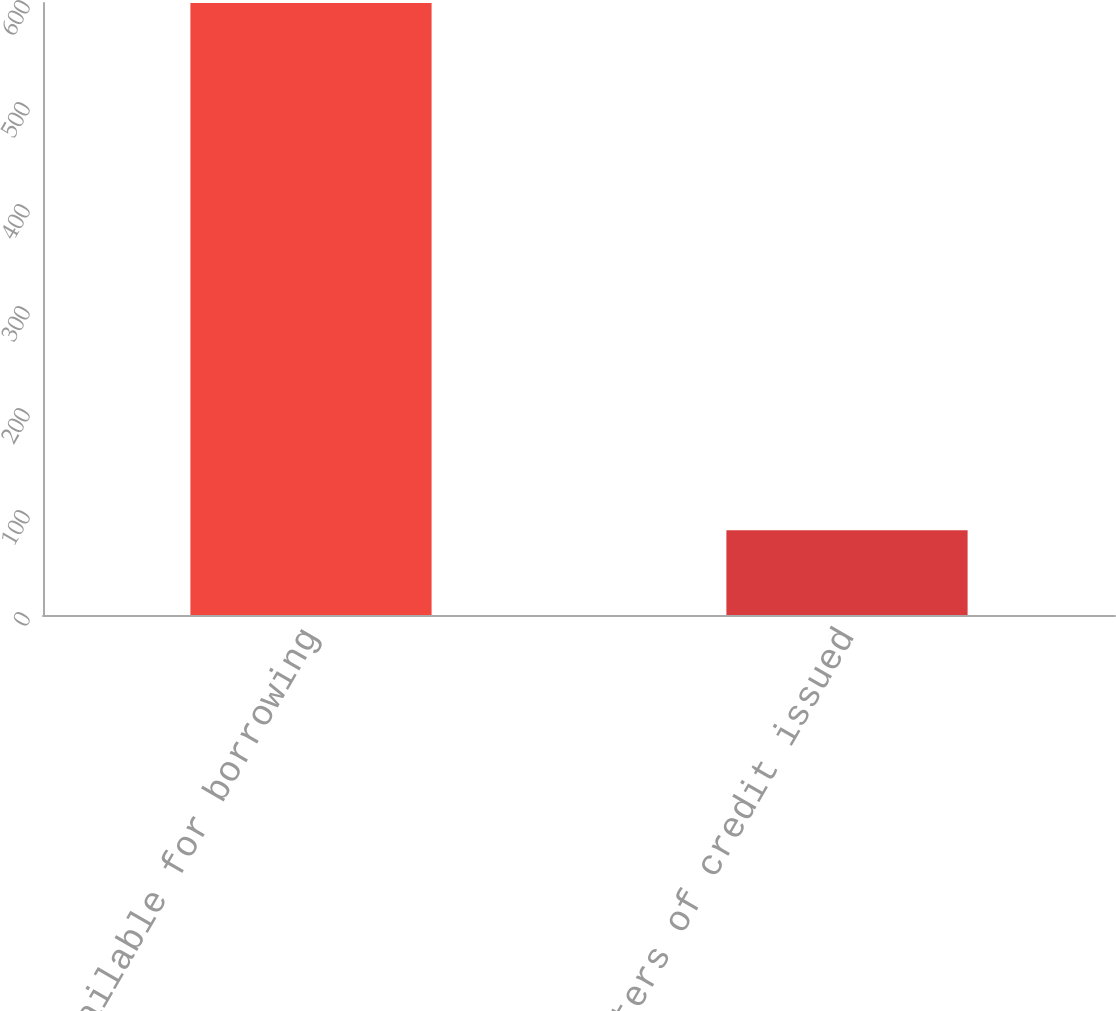Convert chart. <chart><loc_0><loc_0><loc_500><loc_500><bar_chart><fcel>Available for borrowing<fcel>Letters of credit issued<nl><fcel>600<fcel>83<nl></chart> 